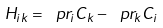<formula> <loc_0><loc_0><loc_500><loc_500>H _ { i k } = \ p r _ { i } C _ { k } - \ p r _ { k } C _ { i }</formula> 